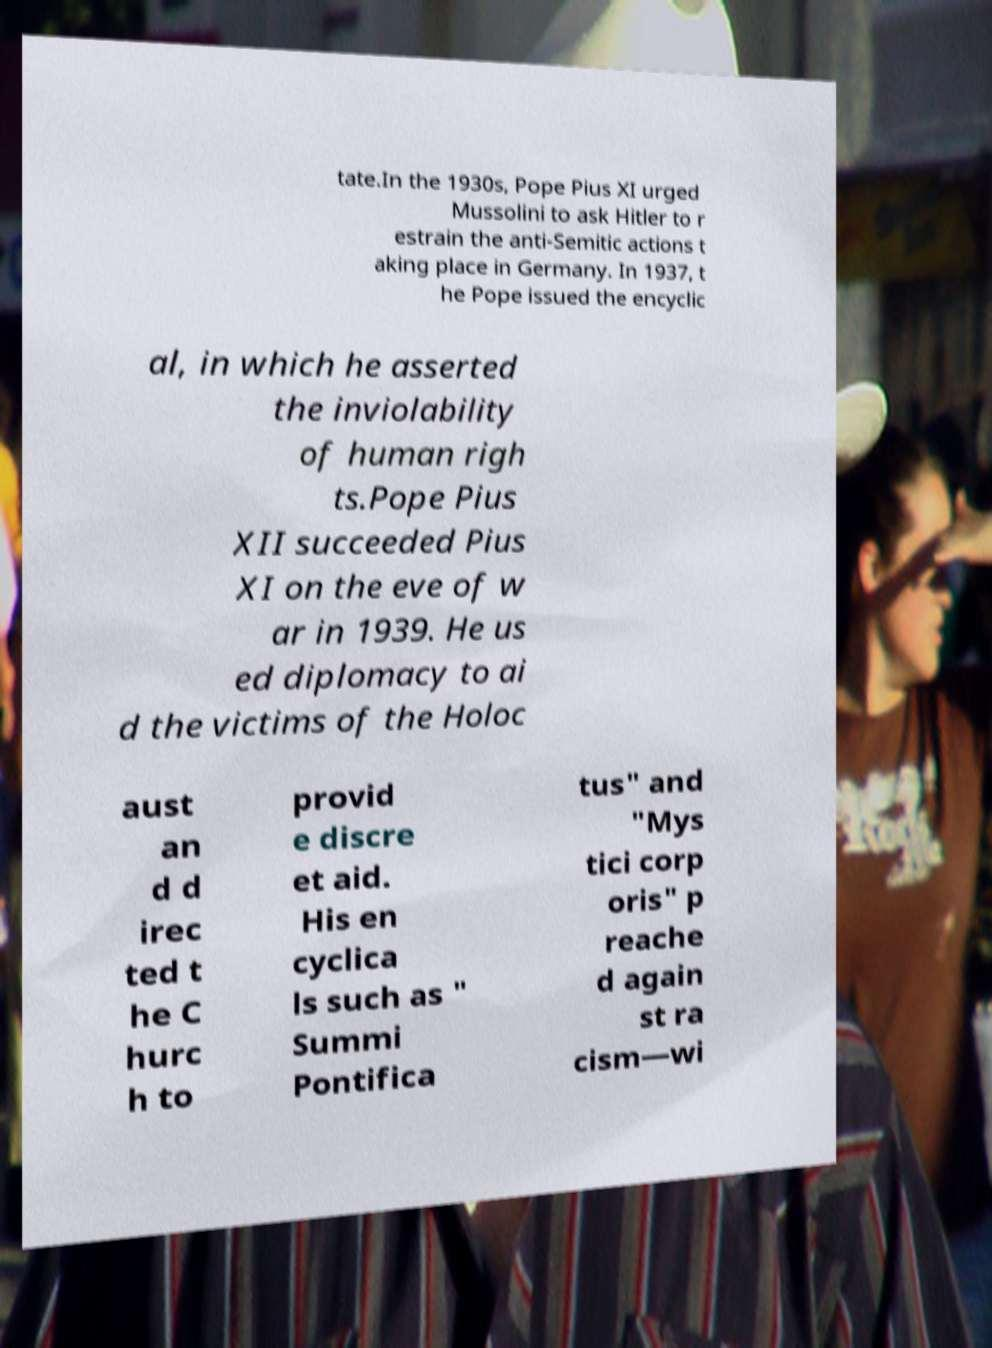Could you extract and type out the text from this image? tate.In the 1930s, Pope Pius XI urged Mussolini to ask Hitler to r estrain the anti-Semitic actions t aking place in Germany. In 1937, t he Pope issued the encyclic al, in which he asserted the inviolability of human righ ts.Pope Pius XII succeeded Pius XI on the eve of w ar in 1939. He us ed diplomacy to ai d the victims of the Holoc aust an d d irec ted t he C hurc h to provid e discre et aid. His en cyclica ls such as " Summi Pontifica tus" and "Mys tici corp oris" p reache d again st ra cism—wi 